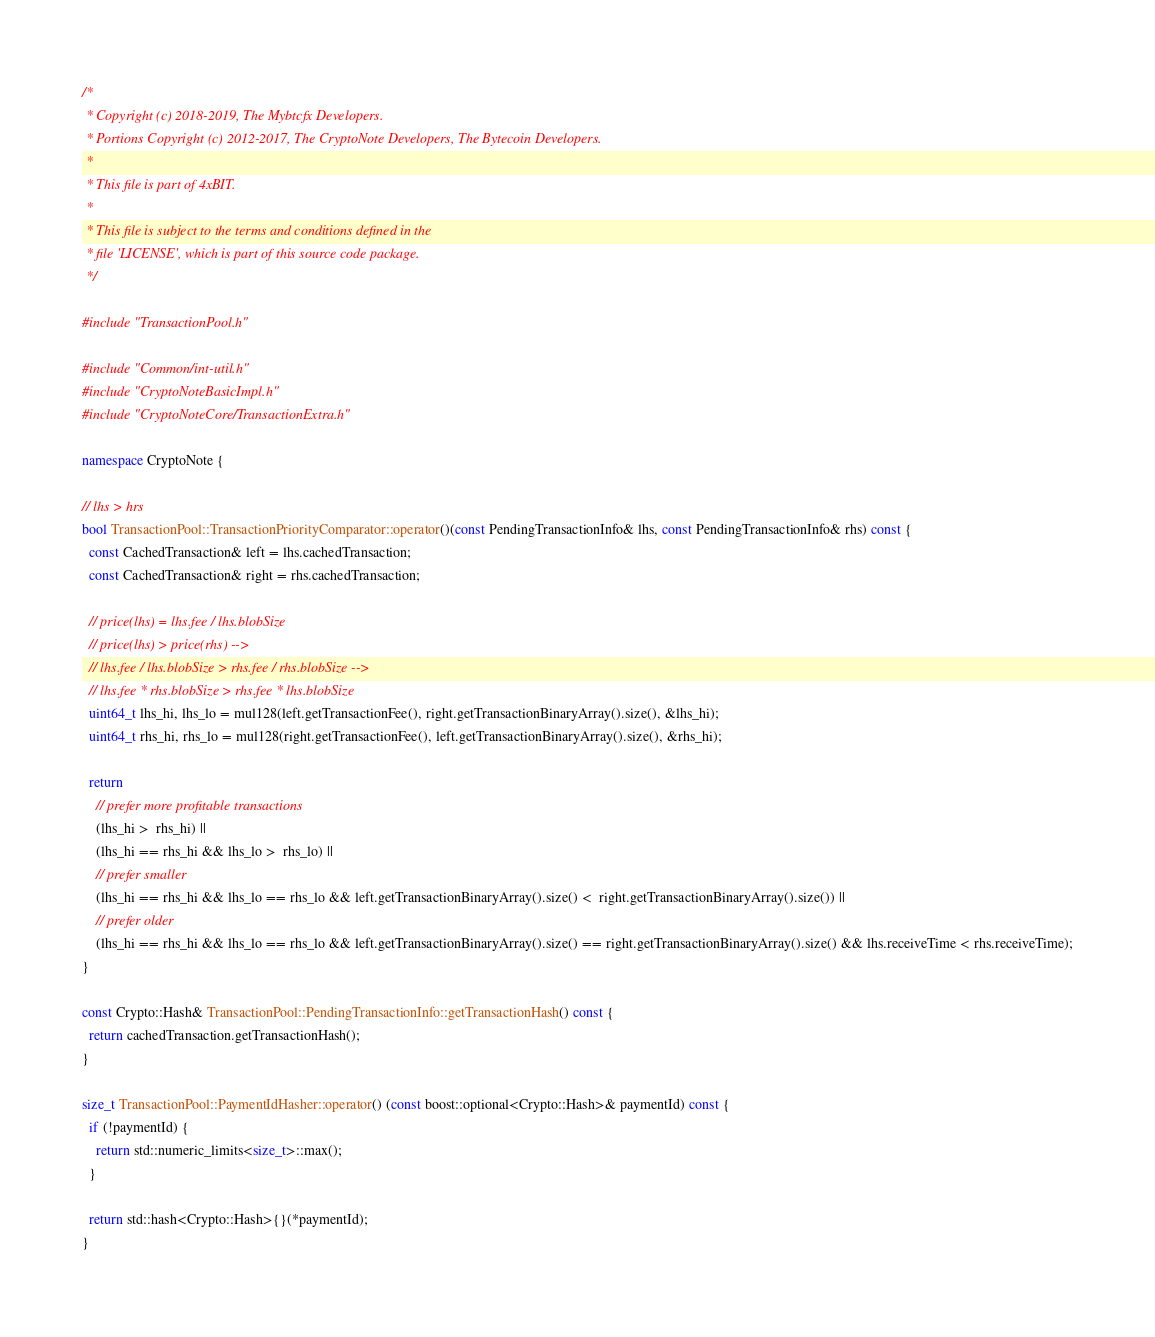<code> <loc_0><loc_0><loc_500><loc_500><_C++_>/*
 * Copyright (c) 2018-2019, The Mybtcfx Developers.
 * Portions Copyright (c) 2012-2017, The CryptoNote Developers, The Bytecoin Developers.
 *
 * This file is part of 4xBIT.
 *
 * This file is subject to the terms and conditions defined in the
 * file 'LICENSE', which is part of this source code package.
 */

#include "TransactionPool.h"

#include "Common/int-util.h"
#include "CryptoNoteBasicImpl.h"
#include "CryptoNoteCore/TransactionExtra.h"

namespace CryptoNote {

// lhs > hrs
bool TransactionPool::TransactionPriorityComparator::operator()(const PendingTransactionInfo& lhs, const PendingTransactionInfo& rhs) const {
  const CachedTransaction& left = lhs.cachedTransaction;
  const CachedTransaction& right = rhs.cachedTransaction;

  // price(lhs) = lhs.fee / lhs.blobSize
  // price(lhs) > price(rhs) -->
  // lhs.fee / lhs.blobSize > rhs.fee / rhs.blobSize -->
  // lhs.fee * rhs.blobSize > rhs.fee * lhs.blobSize
  uint64_t lhs_hi, lhs_lo = mul128(left.getTransactionFee(), right.getTransactionBinaryArray().size(), &lhs_hi);
  uint64_t rhs_hi, rhs_lo = mul128(right.getTransactionFee(), left.getTransactionBinaryArray().size(), &rhs_hi);

  return
    // prefer more profitable transactions
    (lhs_hi >  rhs_hi) ||
    (lhs_hi == rhs_hi && lhs_lo >  rhs_lo) ||
    // prefer smaller
    (lhs_hi == rhs_hi && lhs_lo == rhs_lo && left.getTransactionBinaryArray().size() <  right.getTransactionBinaryArray().size()) ||
    // prefer older
    (lhs_hi == rhs_hi && lhs_lo == rhs_lo && left.getTransactionBinaryArray().size() == right.getTransactionBinaryArray().size() && lhs.receiveTime < rhs.receiveTime);
}

const Crypto::Hash& TransactionPool::PendingTransactionInfo::getTransactionHash() const {
  return cachedTransaction.getTransactionHash();
}

size_t TransactionPool::PaymentIdHasher::operator() (const boost::optional<Crypto::Hash>& paymentId) const {
  if (!paymentId) {
    return std::numeric_limits<size_t>::max();
  }

  return std::hash<Crypto::Hash>{}(*paymentId);
}
</code> 